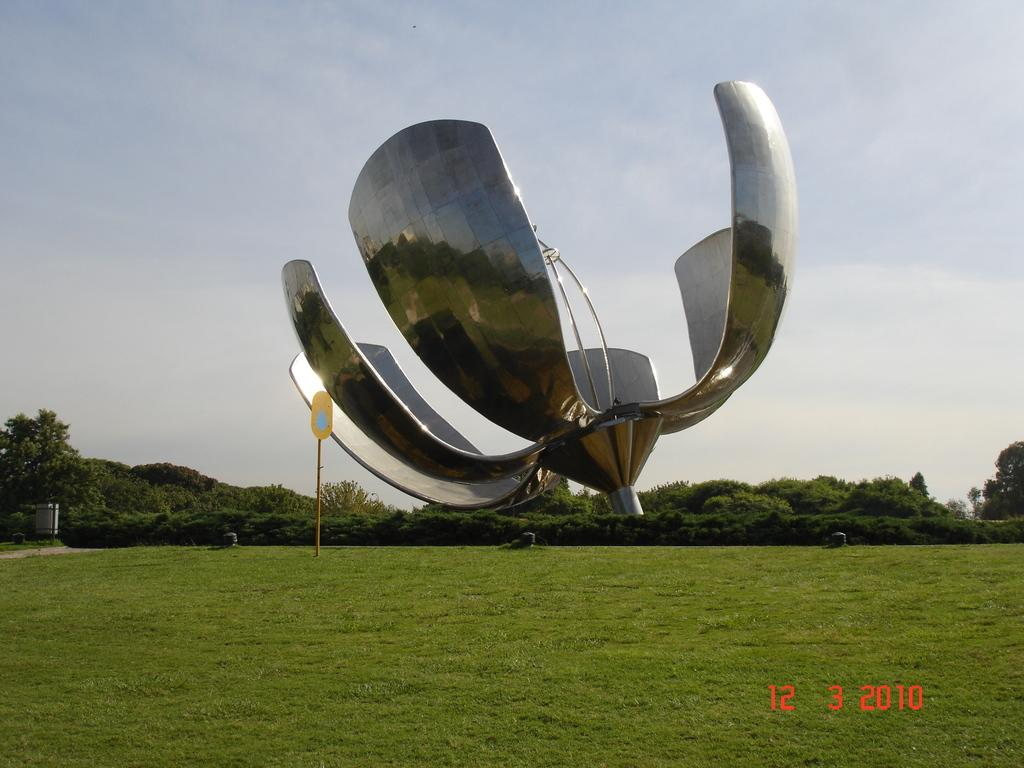What is placed on the grass in the image? There is an object placed on the grass in the image. What type of vegetation can be seen in the image? Trees and grass are visible in the image. How many friends are playing with the dime in the image? There is no dime or friends present in the image. 